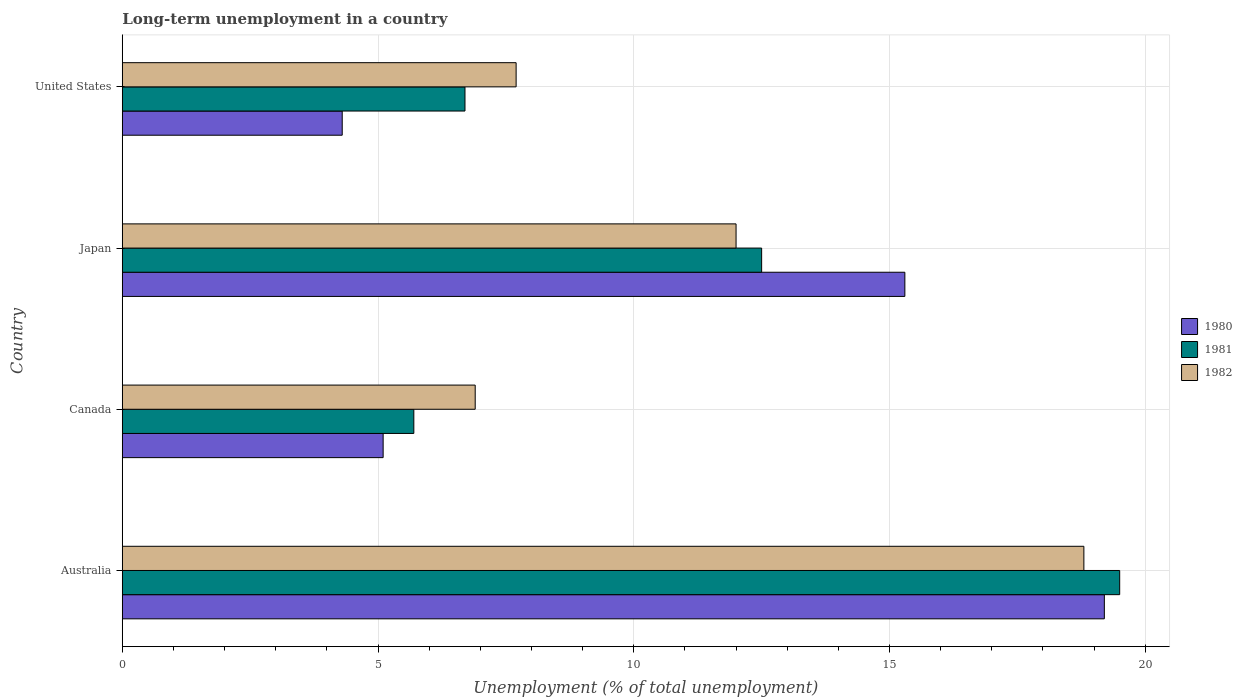How many different coloured bars are there?
Your response must be concise. 3. Are the number of bars on each tick of the Y-axis equal?
Give a very brief answer. Yes. How many bars are there on the 3rd tick from the bottom?
Make the answer very short. 3. What is the percentage of long-term unemployed population in 1980 in Canada?
Provide a succinct answer. 5.1. Across all countries, what is the maximum percentage of long-term unemployed population in 1980?
Provide a short and direct response. 19.2. Across all countries, what is the minimum percentage of long-term unemployed population in 1981?
Keep it short and to the point. 5.7. What is the total percentage of long-term unemployed population in 1982 in the graph?
Your answer should be compact. 45.4. What is the difference between the percentage of long-term unemployed population in 1982 in Australia and that in Canada?
Your answer should be very brief. 11.9. What is the difference between the percentage of long-term unemployed population in 1982 in Canada and the percentage of long-term unemployed population in 1980 in Australia?
Your answer should be compact. -12.3. What is the average percentage of long-term unemployed population in 1982 per country?
Offer a very short reply. 11.35. What is the difference between the percentage of long-term unemployed population in 1981 and percentage of long-term unemployed population in 1982 in Japan?
Offer a very short reply. 0.5. What is the ratio of the percentage of long-term unemployed population in 1980 in Canada to that in Japan?
Your answer should be compact. 0.33. Is the difference between the percentage of long-term unemployed population in 1981 in Australia and Canada greater than the difference between the percentage of long-term unemployed population in 1982 in Australia and Canada?
Offer a very short reply. Yes. What is the difference between the highest and the lowest percentage of long-term unemployed population in 1981?
Keep it short and to the point. 13.8. In how many countries, is the percentage of long-term unemployed population in 1980 greater than the average percentage of long-term unemployed population in 1980 taken over all countries?
Keep it short and to the point. 2. Is the sum of the percentage of long-term unemployed population in 1980 in Japan and United States greater than the maximum percentage of long-term unemployed population in 1982 across all countries?
Ensure brevity in your answer.  Yes. What does the 2nd bar from the top in Australia represents?
Provide a short and direct response. 1981. What does the 2nd bar from the bottom in Japan represents?
Your response must be concise. 1981. Are all the bars in the graph horizontal?
Give a very brief answer. Yes. What is the difference between two consecutive major ticks on the X-axis?
Keep it short and to the point. 5. Does the graph contain any zero values?
Your answer should be compact. No. Does the graph contain grids?
Provide a succinct answer. Yes. Where does the legend appear in the graph?
Offer a terse response. Center right. How many legend labels are there?
Offer a terse response. 3. What is the title of the graph?
Offer a terse response. Long-term unemployment in a country. What is the label or title of the X-axis?
Your answer should be compact. Unemployment (% of total unemployment). What is the label or title of the Y-axis?
Offer a very short reply. Country. What is the Unemployment (% of total unemployment) in 1980 in Australia?
Provide a succinct answer. 19.2. What is the Unemployment (% of total unemployment) of 1981 in Australia?
Your response must be concise. 19.5. What is the Unemployment (% of total unemployment) of 1982 in Australia?
Offer a very short reply. 18.8. What is the Unemployment (% of total unemployment) in 1980 in Canada?
Make the answer very short. 5.1. What is the Unemployment (% of total unemployment) in 1981 in Canada?
Make the answer very short. 5.7. What is the Unemployment (% of total unemployment) in 1982 in Canada?
Your answer should be compact. 6.9. What is the Unemployment (% of total unemployment) of 1980 in Japan?
Your response must be concise. 15.3. What is the Unemployment (% of total unemployment) of 1981 in Japan?
Provide a short and direct response. 12.5. What is the Unemployment (% of total unemployment) in 1980 in United States?
Make the answer very short. 4.3. What is the Unemployment (% of total unemployment) in 1981 in United States?
Provide a short and direct response. 6.7. What is the Unemployment (% of total unemployment) in 1982 in United States?
Offer a terse response. 7.7. Across all countries, what is the maximum Unemployment (% of total unemployment) in 1980?
Give a very brief answer. 19.2. Across all countries, what is the maximum Unemployment (% of total unemployment) of 1982?
Offer a terse response. 18.8. Across all countries, what is the minimum Unemployment (% of total unemployment) of 1980?
Keep it short and to the point. 4.3. Across all countries, what is the minimum Unemployment (% of total unemployment) in 1981?
Give a very brief answer. 5.7. Across all countries, what is the minimum Unemployment (% of total unemployment) of 1982?
Offer a terse response. 6.9. What is the total Unemployment (% of total unemployment) of 1980 in the graph?
Ensure brevity in your answer.  43.9. What is the total Unemployment (% of total unemployment) in 1981 in the graph?
Your response must be concise. 44.4. What is the total Unemployment (% of total unemployment) of 1982 in the graph?
Make the answer very short. 45.4. What is the difference between the Unemployment (% of total unemployment) of 1980 in Australia and that in Canada?
Offer a terse response. 14.1. What is the difference between the Unemployment (% of total unemployment) in 1980 in Australia and that in Japan?
Keep it short and to the point. 3.9. What is the difference between the Unemployment (% of total unemployment) in 1982 in Australia and that in Japan?
Your answer should be compact. 6.8. What is the difference between the Unemployment (% of total unemployment) of 1980 in Australia and that in United States?
Your response must be concise. 14.9. What is the difference between the Unemployment (% of total unemployment) in 1981 in Australia and that in United States?
Provide a short and direct response. 12.8. What is the difference between the Unemployment (% of total unemployment) in 1980 in Canada and that in Japan?
Keep it short and to the point. -10.2. What is the difference between the Unemployment (% of total unemployment) of 1980 in Canada and that in United States?
Give a very brief answer. 0.8. What is the difference between the Unemployment (% of total unemployment) in 1981 in Canada and that in United States?
Your answer should be very brief. -1. What is the difference between the Unemployment (% of total unemployment) in 1982 in Canada and that in United States?
Offer a very short reply. -0.8. What is the difference between the Unemployment (% of total unemployment) of 1980 in Japan and that in United States?
Give a very brief answer. 11. What is the difference between the Unemployment (% of total unemployment) of 1981 in Japan and that in United States?
Give a very brief answer. 5.8. What is the difference between the Unemployment (% of total unemployment) of 1981 in Australia and the Unemployment (% of total unemployment) of 1982 in Canada?
Ensure brevity in your answer.  12.6. What is the difference between the Unemployment (% of total unemployment) in 1980 in Australia and the Unemployment (% of total unemployment) in 1981 in Japan?
Offer a very short reply. 6.7. What is the difference between the Unemployment (% of total unemployment) in 1980 in Australia and the Unemployment (% of total unemployment) in 1982 in Japan?
Offer a very short reply. 7.2. What is the difference between the Unemployment (% of total unemployment) of 1981 in Australia and the Unemployment (% of total unemployment) of 1982 in United States?
Your answer should be compact. 11.8. What is the difference between the Unemployment (% of total unemployment) in 1980 in Canada and the Unemployment (% of total unemployment) in 1981 in Japan?
Give a very brief answer. -7.4. What is the difference between the Unemployment (% of total unemployment) of 1980 in Canada and the Unemployment (% of total unemployment) of 1982 in Japan?
Provide a short and direct response. -6.9. What is the difference between the Unemployment (% of total unemployment) of 1981 in Canada and the Unemployment (% of total unemployment) of 1982 in Japan?
Your response must be concise. -6.3. What is the difference between the Unemployment (% of total unemployment) of 1980 in Canada and the Unemployment (% of total unemployment) of 1981 in United States?
Ensure brevity in your answer.  -1.6. What is the difference between the Unemployment (% of total unemployment) of 1981 in Japan and the Unemployment (% of total unemployment) of 1982 in United States?
Make the answer very short. 4.8. What is the average Unemployment (% of total unemployment) in 1980 per country?
Your response must be concise. 10.97. What is the average Unemployment (% of total unemployment) in 1981 per country?
Your response must be concise. 11.1. What is the average Unemployment (% of total unemployment) of 1982 per country?
Ensure brevity in your answer.  11.35. What is the difference between the Unemployment (% of total unemployment) of 1980 and Unemployment (% of total unemployment) of 1982 in Australia?
Make the answer very short. 0.4. What is the difference between the Unemployment (% of total unemployment) in 1981 and Unemployment (% of total unemployment) in 1982 in Australia?
Provide a succinct answer. 0.7. What is the difference between the Unemployment (% of total unemployment) of 1981 and Unemployment (% of total unemployment) of 1982 in Canada?
Your answer should be compact. -1.2. What is the difference between the Unemployment (% of total unemployment) in 1980 and Unemployment (% of total unemployment) in 1981 in United States?
Make the answer very short. -2.4. What is the difference between the Unemployment (% of total unemployment) in 1980 and Unemployment (% of total unemployment) in 1982 in United States?
Your answer should be very brief. -3.4. What is the ratio of the Unemployment (% of total unemployment) in 1980 in Australia to that in Canada?
Your answer should be compact. 3.76. What is the ratio of the Unemployment (% of total unemployment) in 1981 in Australia to that in Canada?
Keep it short and to the point. 3.42. What is the ratio of the Unemployment (% of total unemployment) of 1982 in Australia to that in Canada?
Your response must be concise. 2.72. What is the ratio of the Unemployment (% of total unemployment) of 1980 in Australia to that in Japan?
Make the answer very short. 1.25. What is the ratio of the Unemployment (% of total unemployment) of 1981 in Australia to that in Japan?
Give a very brief answer. 1.56. What is the ratio of the Unemployment (% of total unemployment) in 1982 in Australia to that in Japan?
Provide a succinct answer. 1.57. What is the ratio of the Unemployment (% of total unemployment) in 1980 in Australia to that in United States?
Provide a succinct answer. 4.47. What is the ratio of the Unemployment (% of total unemployment) in 1981 in Australia to that in United States?
Provide a succinct answer. 2.91. What is the ratio of the Unemployment (% of total unemployment) in 1982 in Australia to that in United States?
Make the answer very short. 2.44. What is the ratio of the Unemployment (% of total unemployment) of 1980 in Canada to that in Japan?
Your answer should be very brief. 0.33. What is the ratio of the Unemployment (% of total unemployment) in 1981 in Canada to that in Japan?
Your answer should be very brief. 0.46. What is the ratio of the Unemployment (% of total unemployment) in 1982 in Canada to that in Japan?
Provide a succinct answer. 0.57. What is the ratio of the Unemployment (% of total unemployment) in 1980 in Canada to that in United States?
Give a very brief answer. 1.19. What is the ratio of the Unemployment (% of total unemployment) in 1981 in Canada to that in United States?
Make the answer very short. 0.85. What is the ratio of the Unemployment (% of total unemployment) of 1982 in Canada to that in United States?
Your answer should be very brief. 0.9. What is the ratio of the Unemployment (% of total unemployment) in 1980 in Japan to that in United States?
Keep it short and to the point. 3.56. What is the ratio of the Unemployment (% of total unemployment) in 1981 in Japan to that in United States?
Offer a terse response. 1.87. What is the ratio of the Unemployment (% of total unemployment) of 1982 in Japan to that in United States?
Make the answer very short. 1.56. What is the difference between the highest and the second highest Unemployment (% of total unemployment) of 1980?
Give a very brief answer. 3.9. What is the difference between the highest and the second highest Unemployment (% of total unemployment) of 1981?
Your answer should be very brief. 7. What is the difference between the highest and the lowest Unemployment (% of total unemployment) in 1980?
Your answer should be compact. 14.9. 